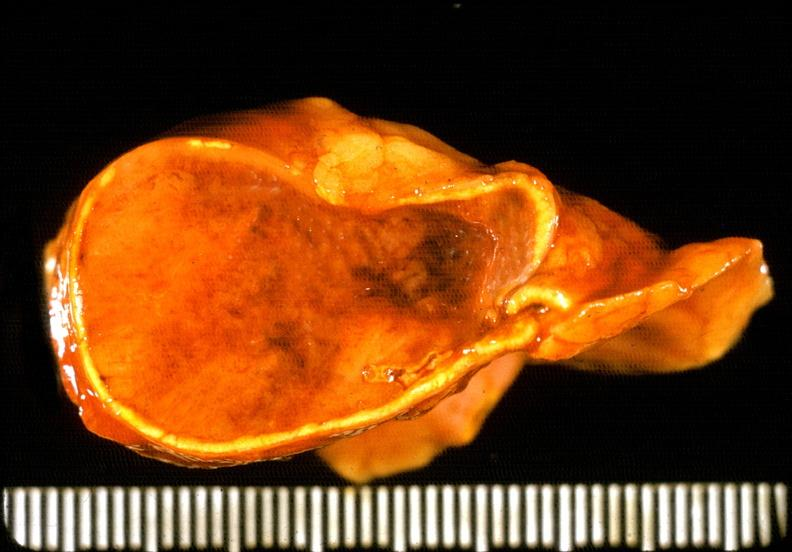s sacrococcygeal teratoma present?
Answer the question using a single word or phrase. No 